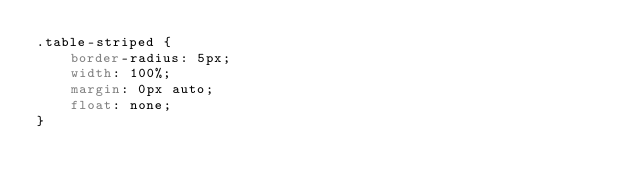<code> <loc_0><loc_0><loc_500><loc_500><_CSS_>.table-striped {
    border-radius: 5px;
    width: 100%;
    margin: 0px auto;
    float: none;
}</code> 